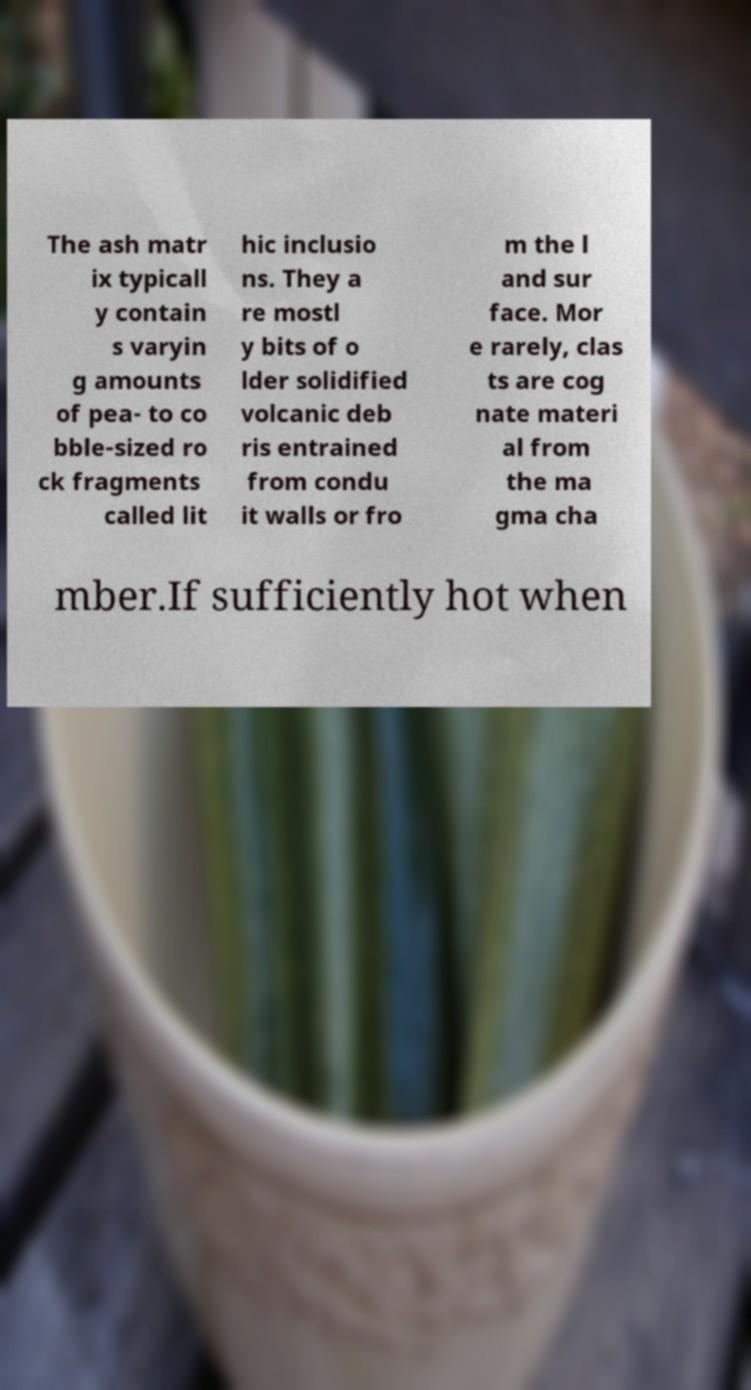There's text embedded in this image that I need extracted. Can you transcribe it verbatim? The ash matr ix typicall y contain s varyin g amounts of pea- to co bble-sized ro ck fragments called lit hic inclusio ns. They a re mostl y bits of o lder solidified volcanic deb ris entrained from condu it walls or fro m the l and sur face. Mor e rarely, clas ts are cog nate materi al from the ma gma cha mber.If sufficiently hot when 